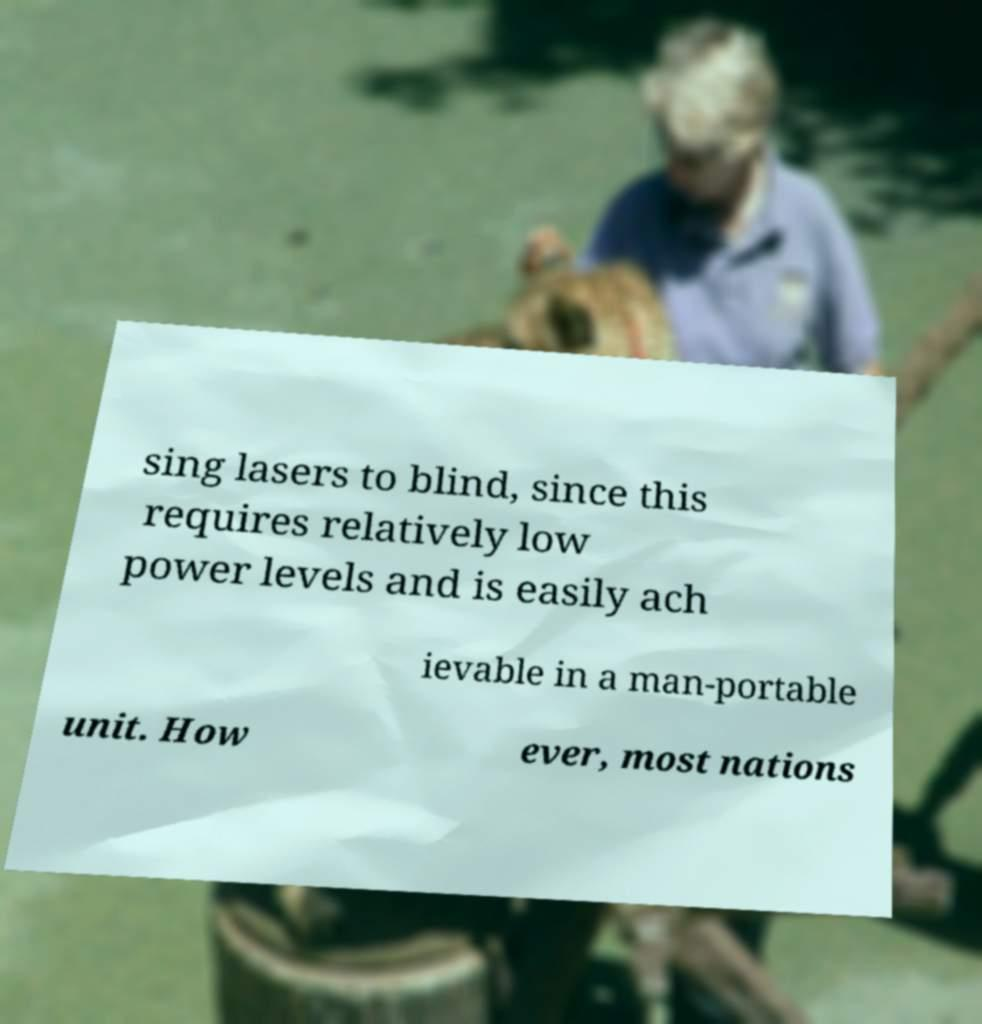I need the written content from this picture converted into text. Can you do that? sing lasers to blind, since this requires relatively low power levels and is easily ach ievable in a man-portable unit. How ever, most nations 